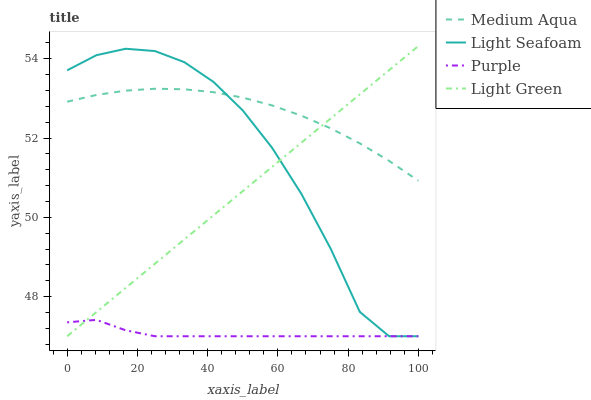Does Purple have the minimum area under the curve?
Answer yes or no. Yes. Does Medium Aqua have the maximum area under the curve?
Answer yes or no. Yes. Does Light Seafoam have the minimum area under the curve?
Answer yes or no. No. Does Light Seafoam have the maximum area under the curve?
Answer yes or no. No. Is Light Green the smoothest?
Answer yes or no. Yes. Is Light Seafoam the roughest?
Answer yes or no. Yes. Is Medium Aqua the smoothest?
Answer yes or no. No. Is Medium Aqua the roughest?
Answer yes or no. No. Does Purple have the lowest value?
Answer yes or no. Yes. Does Medium Aqua have the lowest value?
Answer yes or no. No. Does Light Green have the highest value?
Answer yes or no. Yes. Does Light Seafoam have the highest value?
Answer yes or no. No. Is Purple less than Medium Aqua?
Answer yes or no. Yes. Is Medium Aqua greater than Purple?
Answer yes or no. Yes. Does Light Green intersect Medium Aqua?
Answer yes or no. Yes. Is Light Green less than Medium Aqua?
Answer yes or no. No. Is Light Green greater than Medium Aqua?
Answer yes or no. No. Does Purple intersect Medium Aqua?
Answer yes or no. No. 